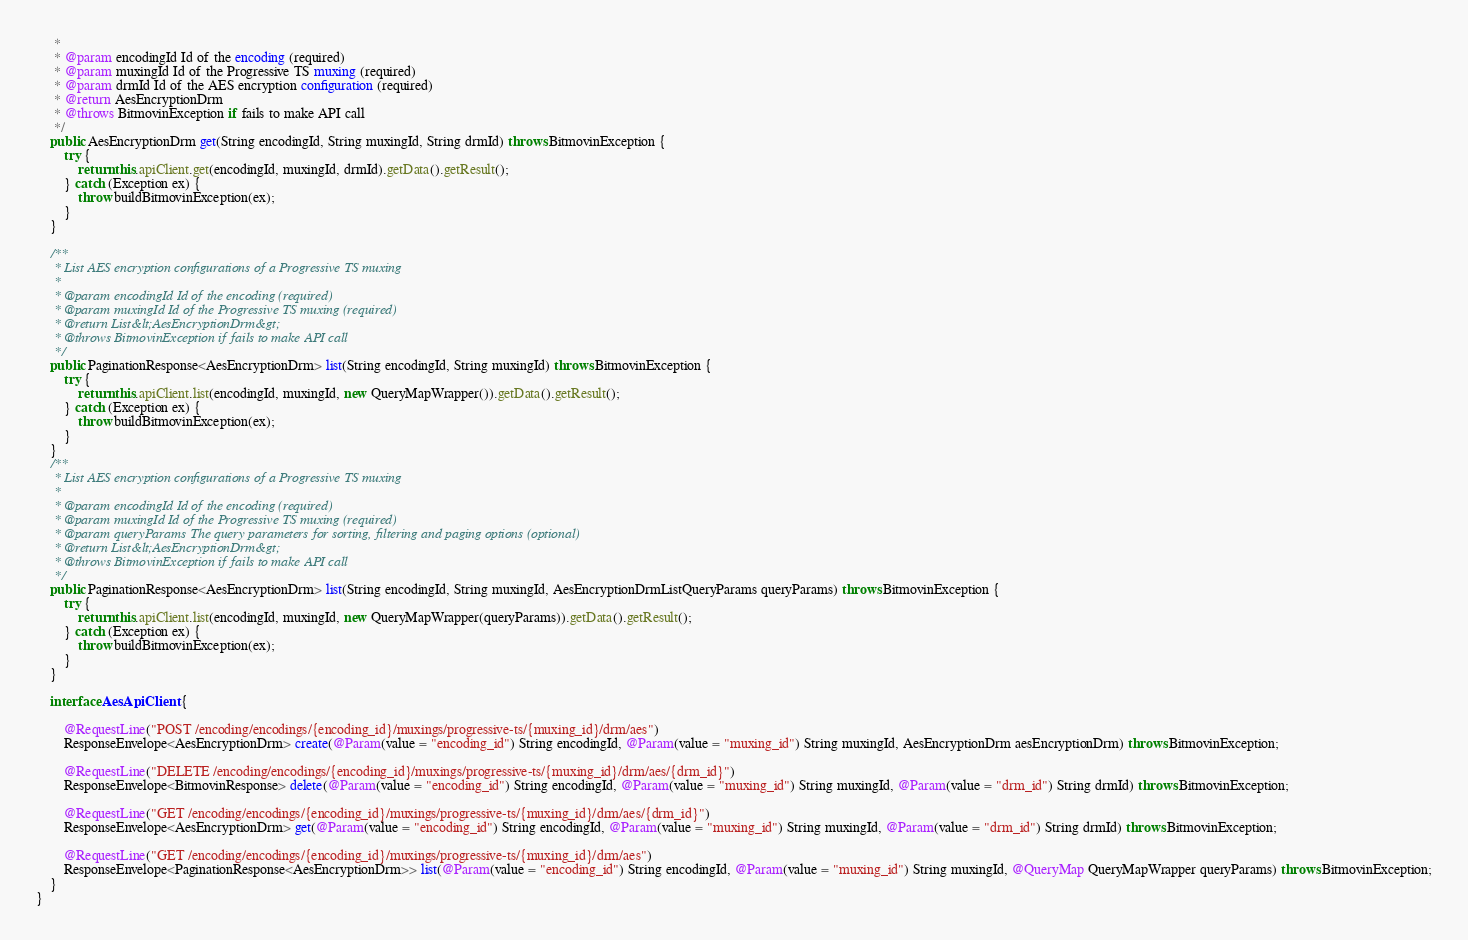<code> <loc_0><loc_0><loc_500><loc_500><_Java_>     * 
     * @param encodingId Id of the encoding (required)
     * @param muxingId Id of the Progressive TS muxing (required)
     * @param drmId Id of the AES encryption configuration (required)
     * @return AesEncryptionDrm
     * @throws BitmovinException if fails to make API call
     */
    public AesEncryptionDrm get(String encodingId, String muxingId, String drmId) throws BitmovinException {
        try {
            return this.apiClient.get(encodingId, muxingId, drmId).getData().getResult();
        } catch (Exception ex) {
            throw buildBitmovinException(ex);
        }
    }
    
    /**
     * List AES encryption configurations of a Progressive TS muxing
     * 
     * @param encodingId Id of the encoding (required)
     * @param muxingId Id of the Progressive TS muxing (required)
     * @return List&lt;AesEncryptionDrm&gt;
     * @throws BitmovinException if fails to make API call
     */
    public PaginationResponse<AesEncryptionDrm> list(String encodingId, String muxingId) throws BitmovinException {
        try {
            return this.apiClient.list(encodingId, muxingId, new QueryMapWrapper()).getData().getResult();
        } catch (Exception ex) {
            throw buildBitmovinException(ex);
        }
    }
    /**
     * List AES encryption configurations of a Progressive TS muxing
     * 
     * @param encodingId Id of the encoding (required)
     * @param muxingId Id of the Progressive TS muxing (required)
     * @param queryParams The query parameters for sorting, filtering and paging options (optional)
     * @return List&lt;AesEncryptionDrm&gt;
     * @throws BitmovinException if fails to make API call
     */
    public PaginationResponse<AesEncryptionDrm> list(String encodingId, String muxingId, AesEncryptionDrmListQueryParams queryParams) throws BitmovinException {
        try {
            return this.apiClient.list(encodingId, muxingId, new QueryMapWrapper(queryParams)).getData().getResult();
        } catch (Exception ex) {
            throw buildBitmovinException(ex);
        }
    }
    
    interface AesApiClient {
    
        @RequestLine("POST /encoding/encodings/{encoding_id}/muxings/progressive-ts/{muxing_id}/drm/aes")
        ResponseEnvelope<AesEncryptionDrm> create(@Param(value = "encoding_id") String encodingId, @Param(value = "muxing_id") String muxingId, AesEncryptionDrm aesEncryptionDrm) throws BitmovinException;
    
        @RequestLine("DELETE /encoding/encodings/{encoding_id}/muxings/progressive-ts/{muxing_id}/drm/aes/{drm_id}")
        ResponseEnvelope<BitmovinResponse> delete(@Param(value = "encoding_id") String encodingId, @Param(value = "muxing_id") String muxingId, @Param(value = "drm_id") String drmId) throws BitmovinException;
    
        @RequestLine("GET /encoding/encodings/{encoding_id}/muxings/progressive-ts/{muxing_id}/drm/aes/{drm_id}")
        ResponseEnvelope<AesEncryptionDrm> get(@Param(value = "encoding_id") String encodingId, @Param(value = "muxing_id") String muxingId, @Param(value = "drm_id") String drmId) throws BitmovinException;
    
        @RequestLine("GET /encoding/encodings/{encoding_id}/muxings/progressive-ts/{muxing_id}/drm/aes")
        ResponseEnvelope<PaginationResponse<AesEncryptionDrm>> list(@Param(value = "encoding_id") String encodingId, @Param(value = "muxing_id") String muxingId, @QueryMap QueryMapWrapper queryParams) throws BitmovinException;
    }
}
</code> 